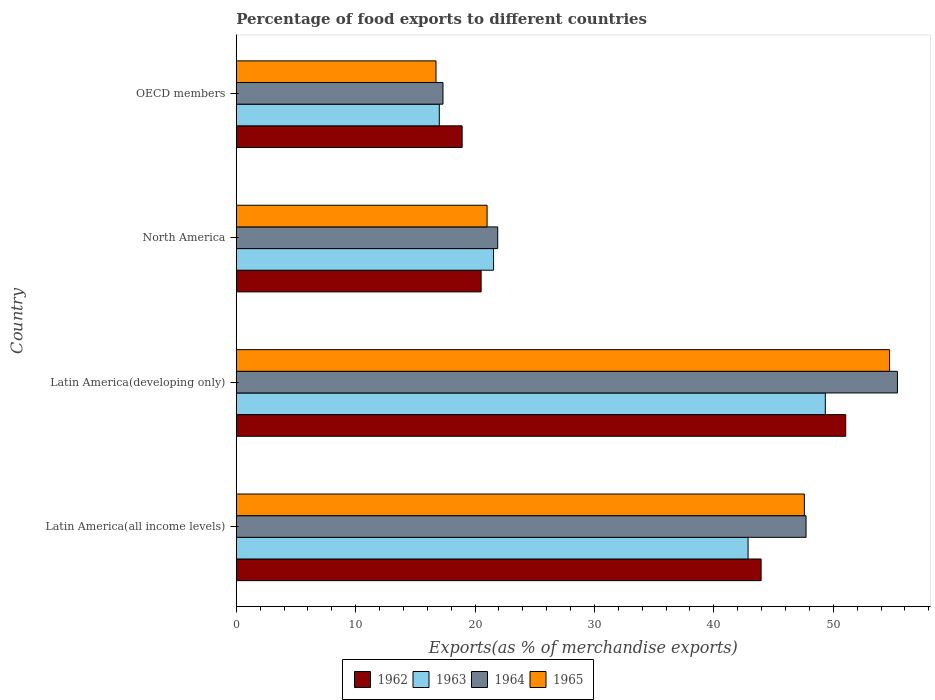Are the number of bars per tick equal to the number of legend labels?
Your response must be concise. Yes. Are the number of bars on each tick of the Y-axis equal?
Keep it short and to the point. Yes. How many bars are there on the 3rd tick from the bottom?
Make the answer very short. 4. What is the label of the 1st group of bars from the top?
Make the answer very short. OECD members. In how many cases, is the number of bars for a given country not equal to the number of legend labels?
Offer a terse response. 0. What is the percentage of exports to different countries in 1962 in Latin America(developing only)?
Provide a succinct answer. 51.04. Across all countries, what is the maximum percentage of exports to different countries in 1965?
Make the answer very short. 54.71. Across all countries, what is the minimum percentage of exports to different countries in 1962?
Offer a very short reply. 18.92. In which country was the percentage of exports to different countries in 1962 maximum?
Your answer should be very brief. Latin America(developing only). In which country was the percentage of exports to different countries in 1963 minimum?
Provide a succinct answer. OECD members. What is the total percentage of exports to different countries in 1962 in the graph?
Make the answer very short. 134.42. What is the difference between the percentage of exports to different countries in 1964 in Latin America(all income levels) and that in North America?
Your answer should be compact. 25.82. What is the difference between the percentage of exports to different countries in 1964 in Latin America(all income levels) and the percentage of exports to different countries in 1962 in Latin America(developing only)?
Your response must be concise. -3.32. What is the average percentage of exports to different countries in 1965 per country?
Offer a very short reply. 35.01. What is the difference between the percentage of exports to different countries in 1962 and percentage of exports to different countries in 1964 in North America?
Your response must be concise. -1.39. In how many countries, is the percentage of exports to different countries in 1963 greater than 42 %?
Provide a succinct answer. 2. What is the ratio of the percentage of exports to different countries in 1964 in Latin America(all income levels) to that in North America?
Your answer should be compact. 2.18. Is the percentage of exports to different countries in 1965 in Latin America(developing only) less than that in North America?
Provide a short and direct response. No. What is the difference between the highest and the second highest percentage of exports to different countries in 1962?
Keep it short and to the point. 7.09. What is the difference between the highest and the lowest percentage of exports to different countries in 1962?
Ensure brevity in your answer.  32.12. In how many countries, is the percentage of exports to different countries in 1962 greater than the average percentage of exports to different countries in 1962 taken over all countries?
Keep it short and to the point. 2. What does the 1st bar from the top in North America represents?
Your answer should be compact. 1965. What does the 2nd bar from the bottom in North America represents?
Your response must be concise. 1963. Is it the case that in every country, the sum of the percentage of exports to different countries in 1963 and percentage of exports to different countries in 1962 is greater than the percentage of exports to different countries in 1964?
Provide a short and direct response. Yes. What is the difference between two consecutive major ticks on the X-axis?
Offer a very short reply. 10. Are the values on the major ticks of X-axis written in scientific E-notation?
Offer a very short reply. No. Where does the legend appear in the graph?
Offer a terse response. Bottom center. How many legend labels are there?
Offer a terse response. 4. What is the title of the graph?
Give a very brief answer. Percentage of food exports to different countries. Does "2002" appear as one of the legend labels in the graph?
Provide a succinct answer. No. What is the label or title of the X-axis?
Provide a short and direct response. Exports(as % of merchandise exports). What is the Exports(as % of merchandise exports) of 1962 in Latin America(all income levels)?
Offer a very short reply. 43.96. What is the Exports(as % of merchandise exports) in 1963 in Latin America(all income levels)?
Keep it short and to the point. 42.86. What is the Exports(as % of merchandise exports) in 1964 in Latin America(all income levels)?
Offer a very short reply. 47.72. What is the Exports(as % of merchandise exports) of 1965 in Latin America(all income levels)?
Ensure brevity in your answer.  47.58. What is the Exports(as % of merchandise exports) in 1962 in Latin America(developing only)?
Keep it short and to the point. 51.04. What is the Exports(as % of merchandise exports) of 1963 in Latin America(developing only)?
Make the answer very short. 49.33. What is the Exports(as % of merchandise exports) of 1964 in Latin America(developing only)?
Your response must be concise. 55.37. What is the Exports(as % of merchandise exports) of 1965 in Latin America(developing only)?
Offer a very short reply. 54.71. What is the Exports(as % of merchandise exports) in 1962 in North America?
Your answer should be compact. 20.51. What is the Exports(as % of merchandise exports) of 1963 in North America?
Make the answer very short. 21.55. What is the Exports(as % of merchandise exports) in 1964 in North America?
Provide a short and direct response. 21.9. What is the Exports(as % of merchandise exports) in 1965 in North America?
Your response must be concise. 21.01. What is the Exports(as % of merchandise exports) in 1962 in OECD members?
Ensure brevity in your answer.  18.92. What is the Exports(as % of merchandise exports) of 1963 in OECD members?
Keep it short and to the point. 17.01. What is the Exports(as % of merchandise exports) of 1964 in OECD members?
Your answer should be very brief. 17.31. What is the Exports(as % of merchandise exports) in 1965 in OECD members?
Ensure brevity in your answer.  16.73. Across all countries, what is the maximum Exports(as % of merchandise exports) in 1962?
Ensure brevity in your answer.  51.04. Across all countries, what is the maximum Exports(as % of merchandise exports) in 1963?
Give a very brief answer. 49.33. Across all countries, what is the maximum Exports(as % of merchandise exports) of 1964?
Keep it short and to the point. 55.37. Across all countries, what is the maximum Exports(as % of merchandise exports) of 1965?
Ensure brevity in your answer.  54.71. Across all countries, what is the minimum Exports(as % of merchandise exports) in 1962?
Your answer should be compact. 18.92. Across all countries, what is the minimum Exports(as % of merchandise exports) in 1963?
Your response must be concise. 17.01. Across all countries, what is the minimum Exports(as % of merchandise exports) in 1964?
Provide a succinct answer. 17.31. Across all countries, what is the minimum Exports(as % of merchandise exports) of 1965?
Offer a terse response. 16.73. What is the total Exports(as % of merchandise exports) in 1962 in the graph?
Your answer should be very brief. 134.42. What is the total Exports(as % of merchandise exports) of 1963 in the graph?
Your response must be concise. 130.75. What is the total Exports(as % of merchandise exports) of 1964 in the graph?
Provide a short and direct response. 142.31. What is the total Exports(as % of merchandise exports) of 1965 in the graph?
Offer a terse response. 140.03. What is the difference between the Exports(as % of merchandise exports) in 1962 in Latin America(all income levels) and that in Latin America(developing only)?
Provide a short and direct response. -7.09. What is the difference between the Exports(as % of merchandise exports) of 1963 in Latin America(all income levels) and that in Latin America(developing only)?
Give a very brief answer. -6.47. What is the difference between the Exports(as % of merchandise exports) of 1964 in Latin America(all income levels) and that in Latin America(developing only)?
Give a very brief answer. -7.65. What is the difference between the Exports(as % of merchandise exports) in 1965 in Latin America(all income levels) and that in Latin America(developing only)?
Give a very brief answer. -7.14. What is the difference between the Exports(as % of merchandise exports) in 1962 in Latin America(all income levels) and that in North America?
Ensure brevity in your answer.  23.45. What is the difference between the Exports(as % of merchandise exports) of 1963 in Latin America(all income levels) and that in North America?
Make the answer very short. 21.32. What is the difference between the Exports(as % of merchandise exports) of 1964 in Latin America(all income levels) and that in North America?
Your response must be concise. 25.82. What is the difference between the Exports(as % of merchandise exports) in 1965 in Latin America(all income levels) and that in North America?
Your answer should be very brief. 26.57. What is the difference between the Exports(as % of merchandise exports) in 1962 in Latin America(all income levels) and that in OECD members?
Make the answer very short. 25.04. What is the difference between the Exports(as % of merchandise exports) in 1963 in Latin America(all income levels) and that in OECD members?
Ensure brevity in your answer.  25.86. What is the difference between the Exports(as % of merchandise exports) of 1964 in Latin America(all income levels) and that in OECD members?
Provide a short and direct response. 30.41. What is the difference between the Exports(as % of merchandise exports) in 1965 in Latin America(all income levels) and that in OECD members?
Offer a terse response. 30.85. What is the difference between the Exports(as % of merchandise exports) in 1962 in Latin America(developing only) and that in North America?
Provide a short and direct response. 30.53. What is the difference between the Exports(as % of merchandise exports) of 1963 in Latin America(developing only) and that in North America?
Your answer should be compact. 27.79. What is the difference between the Exports(as % of merchandise exports) of 1964 in Latin America(developing only) and that in North America?
Your answer should be very brief. 33.48. What is the difference between the Exports(as % of merchandise exports) of 1965 in Latin America(developing only) and that in North America?
Your answer should be compact. 33.71. What is the difference between the Exports(as % of merchandise exports) of 1962 in Latin America(developing only) and that in OECD members?
Your answer should be very brief. 32.12. What is the difference between the Exports(as % of merchandise exports) of 1963 in Latin America(developing only) and that in OECD members?
Your answer should be very brief. 32.33. What is the difference between the Exports(as % of merchandise exports) in 1964 in Latin America(developing only) and that in OECD members?
Keep it short and to the point. 38.06. What is the difference between the Exports(as % of merchandise exports) in 1965 in Latin America(developing only) and that in OECD members?
Your answer should be very brief. 37.99. What is the difference between the Exports(as % of merchandise exports) of 1962 in North America and that in OECD members?
Offer a terse response. 1.59. What is the difference between the Exports(as % of merchandise exports) of 1963 in North America and that in OECD members?
Provide a succinct answer. 4.54. What is the difference between the Exports(as % of merchandise exports) in 1964 in North America and that in OECD members?
Ensure brevity in your answer.  4.58. What is the difference between the Exports(as % of merchandise exports) in 1965 in North America and that in OECD members?
Your response must be concise. 4.28. What is the difference between the Exports(as % of merchandise exports) in 1962 in Latin America(all income levels) and the Exports(as % of merchandise exports) in 1963 in Latin America(developing only)?
Make the answer very short. -5.38. What is the difference between the Exports(as % of merchandise exports) of 1962 in Latin America(all income levels) and the Exports(as % of merchandise exports) of 1964 in Latin America(developing only)?
Make the answer very short. -11.42. What is the difference between the Exports(as % of merchandise exports) of 1962 in Latin America(all income levels) and the Exports(as % of merchandise exports) of 1965 in Latin America(developing only)?
Make the answer very short. -10.76. What is the difference between the Exports(as % of merchandise exports) of 1963 in Latin America(all income levels) and the Exports(as % of merchandise exports) of 1964 in Latin America(developing only)?
Make the answer very short. -12.51. What is the difference between the Exports(as % of merchandise exports) in 1963 in Latin America(all income levels) and the Exports(as % of merchandise exports) in 1965 in Latin America(developing only)?
Make the answer very short. -11.85. What is the difference between the Exports(as % of merchandise exports) in 1964 in Latin America(all income levels) and the Exports(as % of merchandise exports) in 1965 in Latin America(developing only)?
Make the answer very short. -6.99. What is the difference between the Exports(as % of merchandise exports) of 1962 in Latin America(all income levels) and the Exports(as % of merchandise exports) of 1963 in North America?
Ensure brevity in your answer.  22.41. What is the difference between the Exports(as % of merchandise exports) of 1962 in Latin America(all income levels) and the Exports(as % of merchandise exports) of 1964 in North America?
Your answer should be compact. 22.06. What is the difference between the Exports(as % of merchandise exports) of 1962 in Latin America(all income levels) and the Exports(as % of merchandise exports) of 1965 in North America?
Keep it short and to the point. 22.95. What is the difference between the Exports(as % of merchandise exports) of 1963 in Latin America(all income levels) and the Exports(as % of merchandise exports) of 1964 in North America?
Provide a short and direct response. 20.97. What is the difference between the Exports(as % of merchandise exports) in 1963 in Latin America(all income levels) and the Exports(as % of merchandise exports) in 1965 in North America?
Your answer should be very brief. 21.86. What is the difference between the Exports(as % of merchandise exports) of 1964 in Latin America(all income levels) and the Exports(as % of merchandise exports) of 1965 in North America?
Offer a terse response. 26.71. What is the difference between the Exports(as % of merchandise exports) in 1962 in Latin America(all income levels) and the Exports(as % of merchandise exports) in 1963 in OECD members?
Your response must be concise. 26.95. What is the difference between the Exports(as % of merchandise exports) in 1962 in Latin America(all income levels) and the Exports(as % of merchandise exports) in 1964 in OECD members?
Make the answer very short. 26.64. What is the difference between the Exports(as % of merchandise exports) in 1962 in Latin America(all income levels) and the Exports(as % of merchandise exports) in 1965 in OECD members?
Keep it short and to the point. 27.23. What is the difference between the Exports(as % of merchandise exports) in 1963 in Latin America(all income levels) and the Exports(as % of merchandise exports) in 1964 in OECD members?
Keep it short and to the point. 25.55. What is the difference between the Exports(as % of merchandise exports) of 1963 in Latin America(all income levels) and the Exports(as % of merchandise exports) of 1965 in OECD members?
Your response must be concise. 26.14. What is the difference between the Exports(as % of merchandise exports) in 1964 in Latin America(all income levels) and the Exports(as % of merchandise exports) in 1965 in OECD members?
Provide a succinct answer. 30.99. What is the difference between the Exports(as % of merchandise exports) of 1962 in Latin America(developing only) and the Exports(as % of merchandise exports) of 1963 in North America?
Your answer should be compact. 29.49. What is the difference between the Exports(as % of merchandise exports) in 1962 in Latin America(developing only) and the Exports(as % of merchandise exports) in 1964 in North America?
Provide a short and direct response. 29.14. What is the difference between the Exports(as % of merchandise exports) of 1962 in Latin America(developing only) and the Exports(as % of merchandise exports) of 1965 in North America?
Your answer should be very brief. 30.03. What is the difference between the Exports(as % of merchandise exports) in 1963 in Latin America(developing only) and the Exports(as % of merchandise exports) in 1964 in North America?
Offer a very short reply. 27.44. What is the difference between the Exports(as % of merchandise exports) of 1963 in Latin America(developing only) and the Exports(as % of merchandise exports) of 1965 in North America?
Your response must be concise. 28.33. What is the difference between the Exports(as % of merchandise exports) in 1964 in Latin America(developing only) and the Exports(as % of merchandise exports) in 1965 in North America?
Give a very brief answer. 34.37. What is the difference between the Exports(as % of merchandise exports) in 1962 in Latin America(developing only) and the Exports(as % of merchandise exports) in 1963 in OECD members?
Keep it short and to the point. 34.04. What is the difference between the Exports(as % of merchandise exports) of 1962 in Latin America(developing only) and the Exports(as % of merchandise exports) of 1964 in OECD members?
Your answer should be very brief. 33.73. What is the difference between the Exports(as % of merchandise exports) of 1962 in Latin America(developing only) and the Exports(as % of merchandise exports) of 1965 in OECD members?
Make the answer very short. 34.31. What is the difference between the Exports(as % of merchandise exports) in 1963 in Latin America(developing only) and the Exports(as % of merchandise exports) in 1964 in OECD members?
Provide a short and direct response. 32.02. What is the difference between the Exports(as % of merchandise exports) of 1963 in Latin America(developing only) and the Exports(as % of merchandise exports) of 1965 in OECD members?
Your answer should be very brief. 32.61. What is the difference between the Exports(as % of merchandise exports) in 1964 in Latin America(developing only) and the Exports(as % of merchandise exports) in 1965 in OECD members?
Give a very brief answer. 38.64. What is the difference between the Exports(as % of merchandise exports) in 1962 in North America and the Exports(as % of merchandise exports) in 1963 in OECD members?
Your response must be concise. 3.5. What is the difference between the Exports(as % of merchandise exports) in 1962 in North America and the Exports(as % of merchandise exports) in 1964 in OECD members?
Offer a terse response. 3.19. What is the difference between the Exports(as % of merchandise exports) in 1962 in North America and the Exports(as % of merchandise exports) in 1965 in OECD members?
Make the answer very short. 3.78. What is the difference between the Exports(as % of merchandise exports) in 1963 in North America and the Exports(as % of merchandise exports) in 1964 in OECD members?
Offer a very short reply. 4.23. What is the difference between the Exports(as % of merchandise exports) of 1963 in North America and the Exports(as % of merchandise exports) of 1965 in OECD members?
Your answer should be compact. 4.82. What is the difference between the Exports(as % of merchandise exports) in 1964 in North America and the Exports(as % of merchandise exports) in 1965 in OECD members?
Make the answer very short. 5.17. What is the average Exports(as % of merchandise exports) in 1962 per country?
Provide a succinct answer. 33.61. What is the average Exports(as % of merchandise exports) of 1963 per country?
Keep it short and to the point. 32.69. What is the average Exports(as % of merchandise exports) of 1964 per country?
Offer a very short reply. 35.58. What is the average Exports(as % of merchandise exports) of 1965 per country?
Your response must be concise. 35.01. What is the difference between the Exports(as % of merchandise exports) in 1962 and Exports(as % of merchandise exports) in 1963 in Latin America(all income levels)?
Provide a short and direct response. 1.09. What is the difference between the Exports(as % of merchandise exports) of 1962 and Exports(as % of merchandise exports) of 1964 in Latin America(all income levels)?
Offer a very short reply. -3.77. What is the difference between the Exports(as % of merchandise exports) in 1962 and Exports(as % of merchandise exports) in 1965 in Latin America(all income levels)?
Your answer should be very brief. -3.62. What is the difference between the Exports(as % of merchandise exports) of 1963 and Exports(as % of merchandise exports) of 1964 in Latin America(all income levels)?
Provide a short and direct response. -4.86. What is the difference between the Exports(as % of merchandise exports) in 1963 and Exports(as % of merchandise exports) in 1965 in Latin America(all income levels)?
Your answer should be very brief. -4.71. What is the difference between the Exports(as % of merchandise exports) of 1964 and Exports(as % of merchandise exports) of 1965 in Latin America(all income levels)?
Offer a terse response. 0.14. What is the difference between the Exports(as % of merchandise exports) of 1962 and Exports(as % of merchandise exports) of 1963 in Latin America(developing only)?
Your answer should be very brief. 1.71. What is the difference between the Exports(as % of merchandise exports) in 1962 and Exports(as % of merchandise exports) in 1964 in Latin America(developing only)?
Give a very brief answer. -4.33. What is the difference between the Exports(as % of merchandise exports) of 1962 and Exports(as % of merchandise exports) of 1965 in Latin America(developing only)?
Your response must be concise. -3.67. What is the difference between the Exports(as % of merchandise exports) in 1963 and Exports(as % of merchandise exports) in 1964 in Latin America(developing only)?
Provide a succinct answer. -6.04. What is the difference between the Exports(as % of merchandise exports) in 1963 and Exports(as % of merchandise exports) in 1965 in Latin America(developing only)?
Your answer should be very brief. -5.38. What is the difference between the Exports(as % of merchandise exports) in 1964 and Exports(as % of merchandise exports) in 1965 in Latin America(developing only)?
Offer a terse response. 0.66. What is the difference between the Exports(as % of merchandise exports) of 1962 and Exports(as % of merchandise exports) of 1963 in North America?
Keep it short and to the point. -1.04. What is the difference between the Exports(as % of merchandise exports) in 1962 and Exports(as % of merchandise exports) in 1964 in North America?
Provide a succinct answer. -1.39. What is the difference between the Exports(as % of merchandise exports) in 1962 and Exports(as % of merchandise exports) in 1965 in North America?
Provide a succinct answer. -0.5. What is the difference between the Exports(as % of merchandise exports) in 1963 and Exports(as % of merchandise exports) in 1964 in North America?
Give a very brief answer. -0.35. What is the difference between the Exports(as % of merchandise exports) of 1963 and Exports(as % of merchandise exports) of 1965 in North America?
Your answer should be very brief. 0.54. What is the difference between the Exports(as % of merchandise exports) of 1964 and Exports(as % of merchandise exports) of 1965 in North America?
Offer a terse response. 0.89. What is the difference between the Exports(as % of merchandise exports) in 1962 and Exports(as % of merchandise exports) in 1963 in OECD members?
Give a very brief answer. 1.91. What is the difference between the Exports(as % of merchandise exports) of 1962 and Exports(as % of merchandise exports) of 1964 in OECD members?
Your answer should be compact. 1.6. What is the difference between the Exports(as % of merchandise exports) of 1962 and Exports(as % of merchandise exports) of 1965 in OECD members?
Ensure brevity in your answer.  2.19. What is the difference between the Exports(as % of merchandise exports) of 1963 and Exports(as % of merchandise exports) of 1964 in OECD members?
Provide a succinct answer. -0.31. What is the difference between the Exports(as % of merchandise exports) in 1963 and Exports(as % of merchandise exports) in 1965 in OECD members?
Give a very brief answer. 0.28. What is the difference between the Exports(as % of merchandise exports) in 1964 and Exports(as % of merchandise exports) in 1965 in OECD members?
Ensure brevity in your answer.  0.59. What is the ratio of the Exports(as % of merchandise exports) in 1962 in Latin America(all income levels) to that in Latin America(developing only)?
Your response must be concise. 0.86. What is the ratio of the Exports(as % of merchandise exports) in 1963 in Latin America(all income levels) to that in Latin America(developing only)?
Your answer should be very brief. 0.87. What is the ratio of the Exports(as % of merchandise exports) in 1964 in Latin America(all income levels) to that in Latin America(developing only)?
Make the answer very short. 0.86. What is the ratio of the Exports(as % of merchandise exports) of 1965 in Latin America(all income levels) to that in Latin America(developing only)?
Ensure brevity in your answer.  0.87. What is the ratio of the Exports(as % of merchandise exports) of 1962 in Latin America(all income levels) to that in North America?
Ensure brevity in your answer.  2.14. What is the ratio of the Exports(as % of merchandise exports) of 1963 in Latin America(all income levels) to that in North America?
Provide a succinct answer. 1.99. What is the ratio of the Exports(as % of merchandise exports) in 1964 in Latin America(all income levels) to that in North America?
Offer a very short reply. 2.18. What is the ratio of the Exports(as % of merchandise exports) of 1965 in Latin America(all income levels) to that in North America?
Keep it short and to the point. 2.26. What is the ratio of the Exports(as % of merchandise exports) of 1962 in Latin America(all income levels) to that in OECD members?
Your answer should be compact. 2.32. What is the ratio of the Exports(as % of merchandise exports) of 1963 in Latin America(all income levels) to that in OECD members?
Ensure brevity in your answer.  2.52. What is the ratio of the Exports(as % of merchandise exports) in 1964 in Latin America(all income levels) to that in OECD members?
Ensure brevity in your answer.  2.76. What is the ratio of the Exports(as % of merchandise exports) of 1965 in Latin America(all income levels) to that in OECD members?
Your response must be concise. 2.84. What is the ratio of the Exports(as % of merchandise exports) in 1962 in Latin America(developing only) to that in North America?
Give a very brief answer. 2.49. What is the ratio of the Exports(as % of merchandise exports) in 1963 in Latin America(developing only) to that in North America?
Your answer should be compact. 2.29. What is the ratio of the Exports(as % of merchandise exports) of 1964 in Latin America(developing only) to that in North America?
Provide a succinct answer. 2.53. What is the ratio of the Exports(as % of merchandise exports) of 1965 in Latin America(developing only) to that in North America?
Provide a short and direct response. 2.6. What is the ratio of the Exports(as % of merchandise exports) of 1962 in Latin America(developing only) to that in OECD members?
Your answer should be very brief. 2.7. What is the ratio of the Exports(as % of merchandise exports) in 1963 in Latin America(developing only) to that in OECD members?
Keep it short and to the point. 2.9. What is the ratio of the Exports(as % of merchandise exports) of 1964 in Latin America(developing only) to that in OECD members?
Provide a succinct answer. 3.2. What is the ratio of the Exports(as % of merchandise exports) of 1965 in Latin America(developing only) to that in OECD members?
Offer a very short reply. 3.27. What is the ratio of the Exports(as % of merchandise exports) in 1962 in North America to that in OECD members?
Make the answer very short. 1.08. What is the ratio of the Exports(as % of merchandise exports) in 1963 in North America to that in OECD members?
Offer a terse response. 1.27. What is the ratio of the Exports(as % of merchandise exports) in 1964 in North America to that in OECD members?
Your answer should be very brief. 1.26. What is the ratio of the Exports(as % of merchandise exports) in 1965 in North America to that in OECD members?
Offer a very short reply. 1.26. What is the difference between the highest and the second highest Exports(as % of merchandise exports) in 1962?
Make the answer very short. 7.09. What is the difference between the highest and the second highest Exports(as % of merchandise exports) in 1963?
Your answer should be very brief. 6.47. What is the difference between the highest and the second highest Exports(as % of merchandise exports) of 1964?
Make the answer very short. 7.65. What is the difference between the highest and the second highest Exports(as % of merchandise exports) of 1965?
Provide a succinct answer. 7.14. What is the difference between the highest and the lowest Exports(as % of merchandise exports) of 1962?
Provide a succinct answer. 32.12. What is the difference between the highest and the lowest Exports(as % of merchandise exports) in 1963?
Your answer should be compact. 32.33. What is the difference between the highest and the lowest Exports(as % of merchandise exports) in 1964?
Offer a very short reply. 38.06. What is the difference between the highest and the lowest Exports(as % of merchandise exports) of 1965?
Provide a succinct answer. 37.99. 